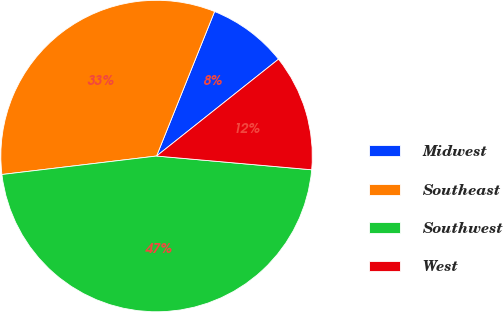<chart> <loc_0><loc_0><loc_500><loc_500><pie_chart><fcel>Midwest<fcel>Southeast<fcel>Southwest<fcel>West<nl><fcel>8.24%<fcel>32.97%<fcel>46.7%<fcel>12.09%<nl></chart> 